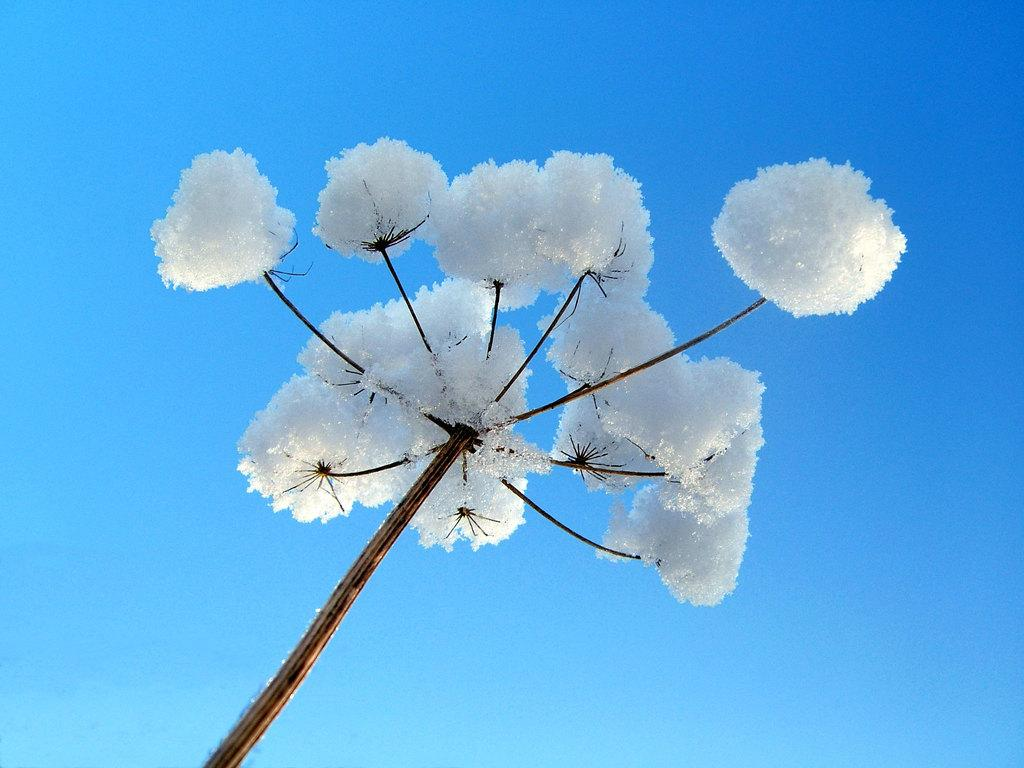What is the main subject of the image? There is a cotton plant in the center of the image. How many squirrels can be seen climbing on the cotton plant in the image? There are no squirrels present in the image; it features a cotton plant. 